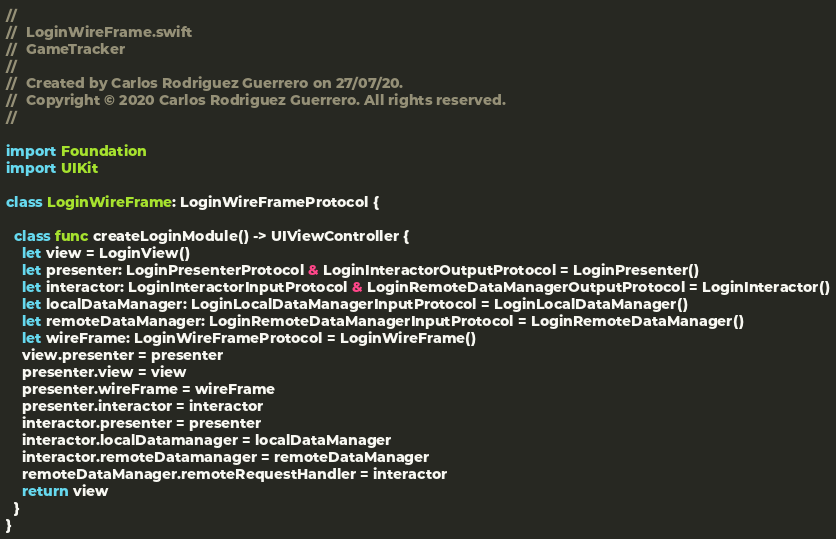<code> <loc_0><loc_0><loc_500><loc_500><_Swift_>//
//  LoginWireFrame.swift
//  GameTracker
//
//  Created by Carlos Rodriguez Guerrero on 27/07/20.
//  Copyright © 2020 Carlos Rodriguez Guerrero. All rights reserved.
//

import Foundation
import UIKit

class LoginWireFrame: LoginWireFrameProtocol {

  class func createLoginModule() -> UIViewController {
    let view = LoginView()
    let presenter: LoginPresenterProtocol & LoginInteractorOutputProtocol = LoginPresenter()
    let interactor: LoginInteractorInputProtocol & LoginRemoteDataManagerOutputProtocol = LoginInteractor()
    let localDataManager: LoginLocalDataManagerInputProtocol = LoginLocalDataManager()
    let remoteDataManager: LoginRemoteDataManagerInputProtocol = LoginRemoteDataManager()
    let wireFrame: LoginWireFrameProtocol = LoginWireFrame()
    view.presenter = presenter
    presenter.view = view
    presenter.wireFrame = wireFrame
    presenter.interactor = interactor
    interactor.presenter = presenter
    interactor.localDatamanager = localDataManager
    interactor.remoteDatamanager = remoteDataManager
    remoteDataManager.remoteRequestHandler = interactor
    return view
  }
}
</code> 